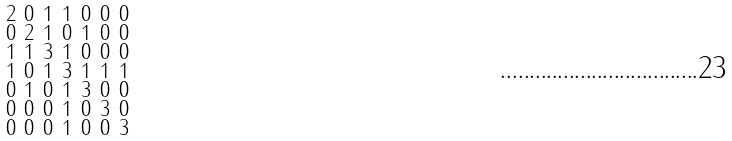<formula> <loc_0><loc_0><loc_500><loc_500>\begin{smallmatrix} 2 & 0 & 1 & 1 & 0 & 0 & 0 \\ 0 & 2 & 1 & 0 & 1 & 0 & 0 \\ 1 & 1 & 3 & 1 & 0 & 0 & 0 \\ 1 & 0 & 1 & 3 & 1 & 1 & 1 \\ 0 & 1 & 0 & 1 & 3 & 0 & 0 \\ 0 & 0 & 0 & 1 & 0 & 3 & 0 \\ 0 & 0 & 0 & 1 & 0 & 0 & 3 \end{smallmatrix}</formula> 